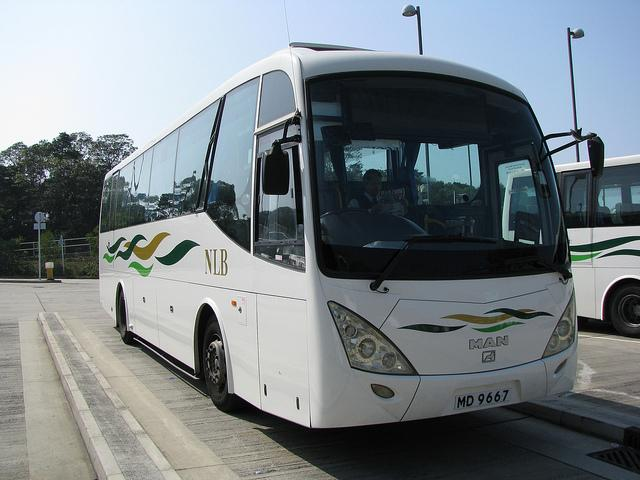What country does this bus originate from?

Choices:
A) italy
B) russia
C) germany
D) hong kong hong kong 